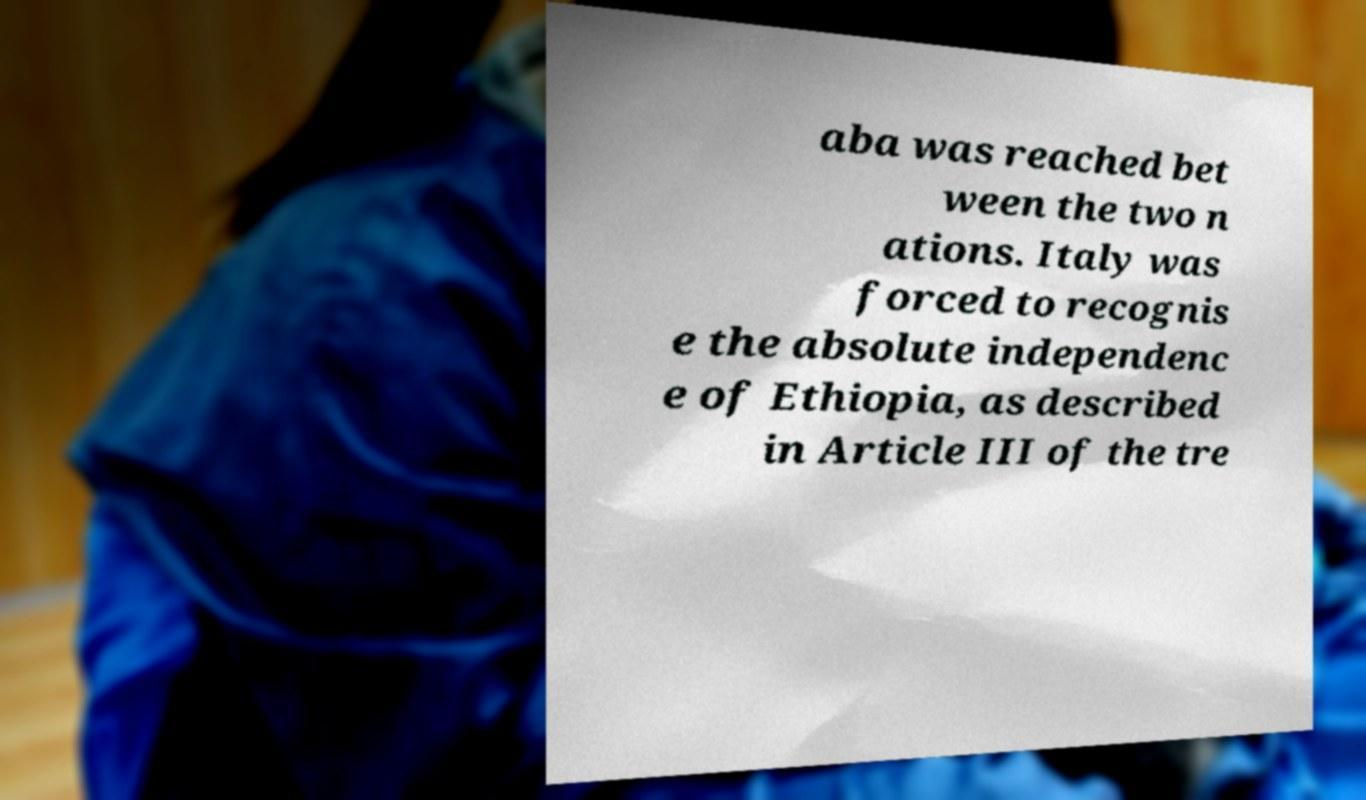There's text embedded in this image that I need extracted. Can you transcribe it verbatim? aba was reached bet ween the two n ations. Italy was forced to recognis e the absolute independenc e of Ethiopia, as described in Article III of the tre 